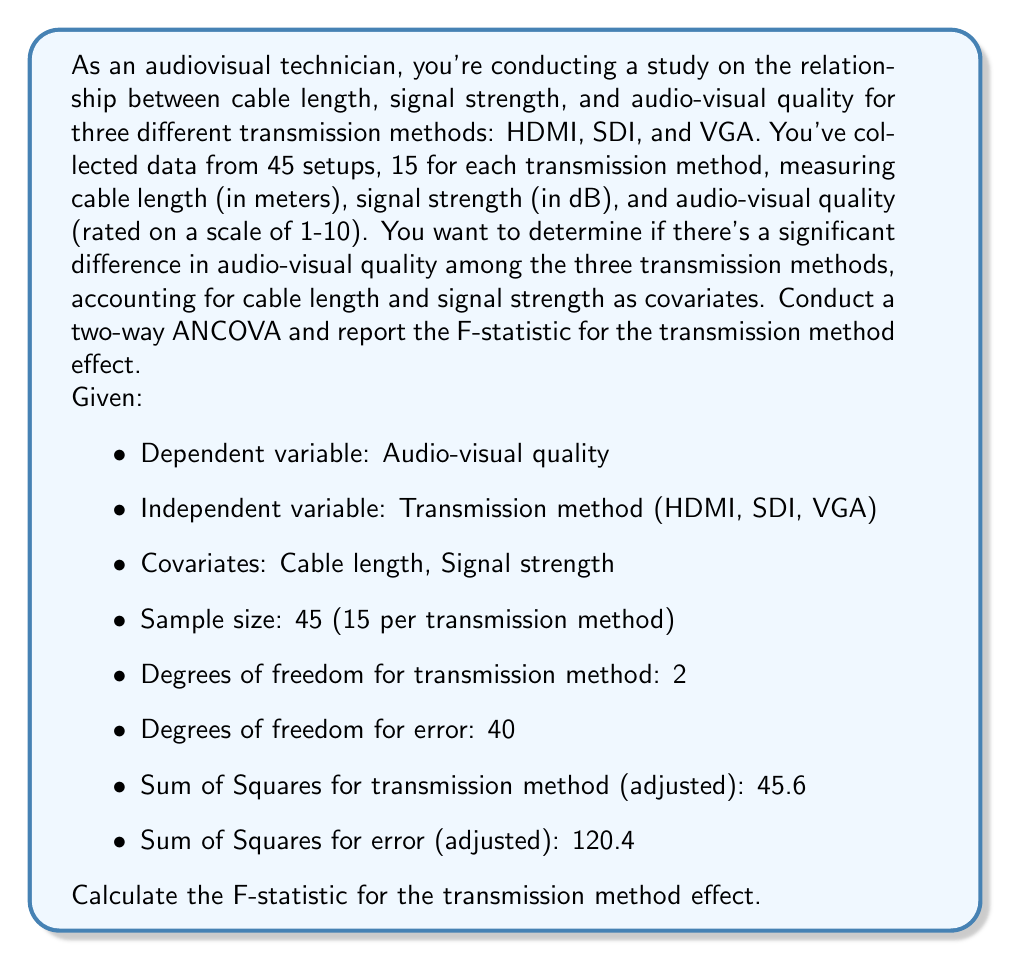Help me with this question. To solve this problem, we'll use a two-way Analysis of Covariance (ANCOVA) to examine the effect of transmission method on audio-visual quality while controlling for cable length and signal strength. The F-statistic will help us determine if there's a significant difference in audio-visual quality among the three transmission methods.

Step 1: Identify the components needed for the F-statistic calculation.
- Degrees of freedom for transmission method (df_treatment) = 2
- Degrees of freedom for error (df_error) = 40
- Sum of Squares for transmission method (SS_treatment) = 45.6
- Sum of Squares for error (SS_error) = 120.4

Step 2: Calculate the Mean Square for transmission method (MS_treatment).
$$MS_{treatment} = \frac{SS_{treatment}}{df_{treatment}} = \frac{45.6}{2} = 22.8$$

Step 3: Calculate the Mean Square for error (MS_error).
$$MS_{error} = \frac{SS_{error}}{df_{error}} = \frac{120.4}{40} = 3.01$$

Step 4: Calculate the F-statistic.
The F-statistic is the ratio of the Mean Square for treatment to the Mean Square for error:

$$F = \frac{MS_{treatment}}{MS_{error}} = \frac{22.8}{3.01} \approx 7.57$$

This F-statistic represents the ratio of variance explained by the transmission method to the unexplained variance, after accounting for the covariates (cable length and signal strength).
Answer: The F-statistic for the transmission method effect is approximately 7.57. 